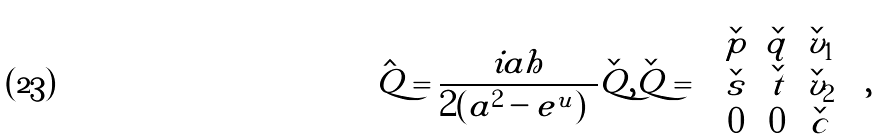Convert formula to latex. <formula><loc_0><loc_0><loc_500><loc_500>\hat { Q } = \frac { i a h } { 2 ( | a | ^ { 2 } - e ^ { u } ) } \check { Q } , \check { Q } = \begin{pmatrix} \check { p } & \check { q } & \check { v } _ { 1 } \\ \check { s } & \check { t } & \check { v } _ { 2 } \\ 0 & 0 & \check { c } \end{pmatrix} ,</formula> 